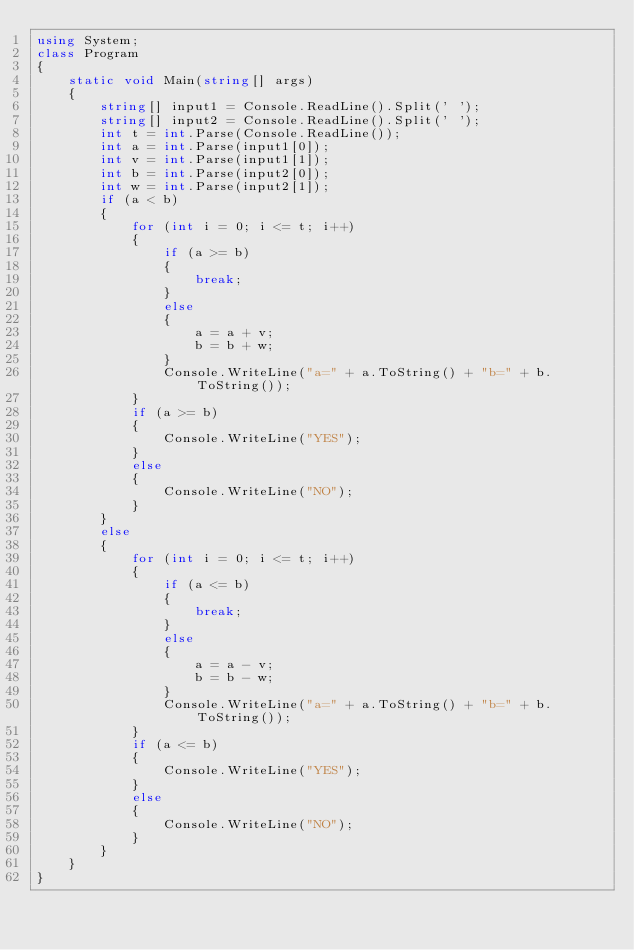<code> <loc_0><loc_0><loc_500><loc_500><_C#_>using System;
class Program
{
	static void Main(string[] args)
	{
		string[] input1 = Console.ReadLine().Split(' ');
		string[] input2 = Console.ReadLine().Split(' ');
		int t = int.Parse(Console.ReadLine());
		int a = int.Parse(input1[0]);
		int v = int.Parse(input1[1]);
		int b = int.Parse(input2[0]);
		int w = int.Parse(input2[1]);
		if (a < b)
		{
			for (int i = 0; i <= t; i++)
			{
				if (a >= b)
				{
					break;
				}
				else
				{
					a = a + v;
					b = b + w;
				}
				Console.WriteLine("a=" + a.ToString() + "b=" + b.ToString());
			}
			if (a >= b)
			{
				Console.WriteLine("YES");
			}
			else
			{
				Console.WriteLine("NO");
			}
		}
		else
		{
			for (int i = 0; i <= t; i++)
			{
				if (a <= b)
				{
					break;
				}
				else
				{
					a = a - v;
					b = b - w;
				}
				Console.WriteLine("a=" + a.ToString() + "b=" + b.ToString());
			}
			if (a <= b)
			{
				Console.WriteLine("YES");
			}
			else
			{
				Console.WriteLine("NO");
			}
		}
	}
}</code> 